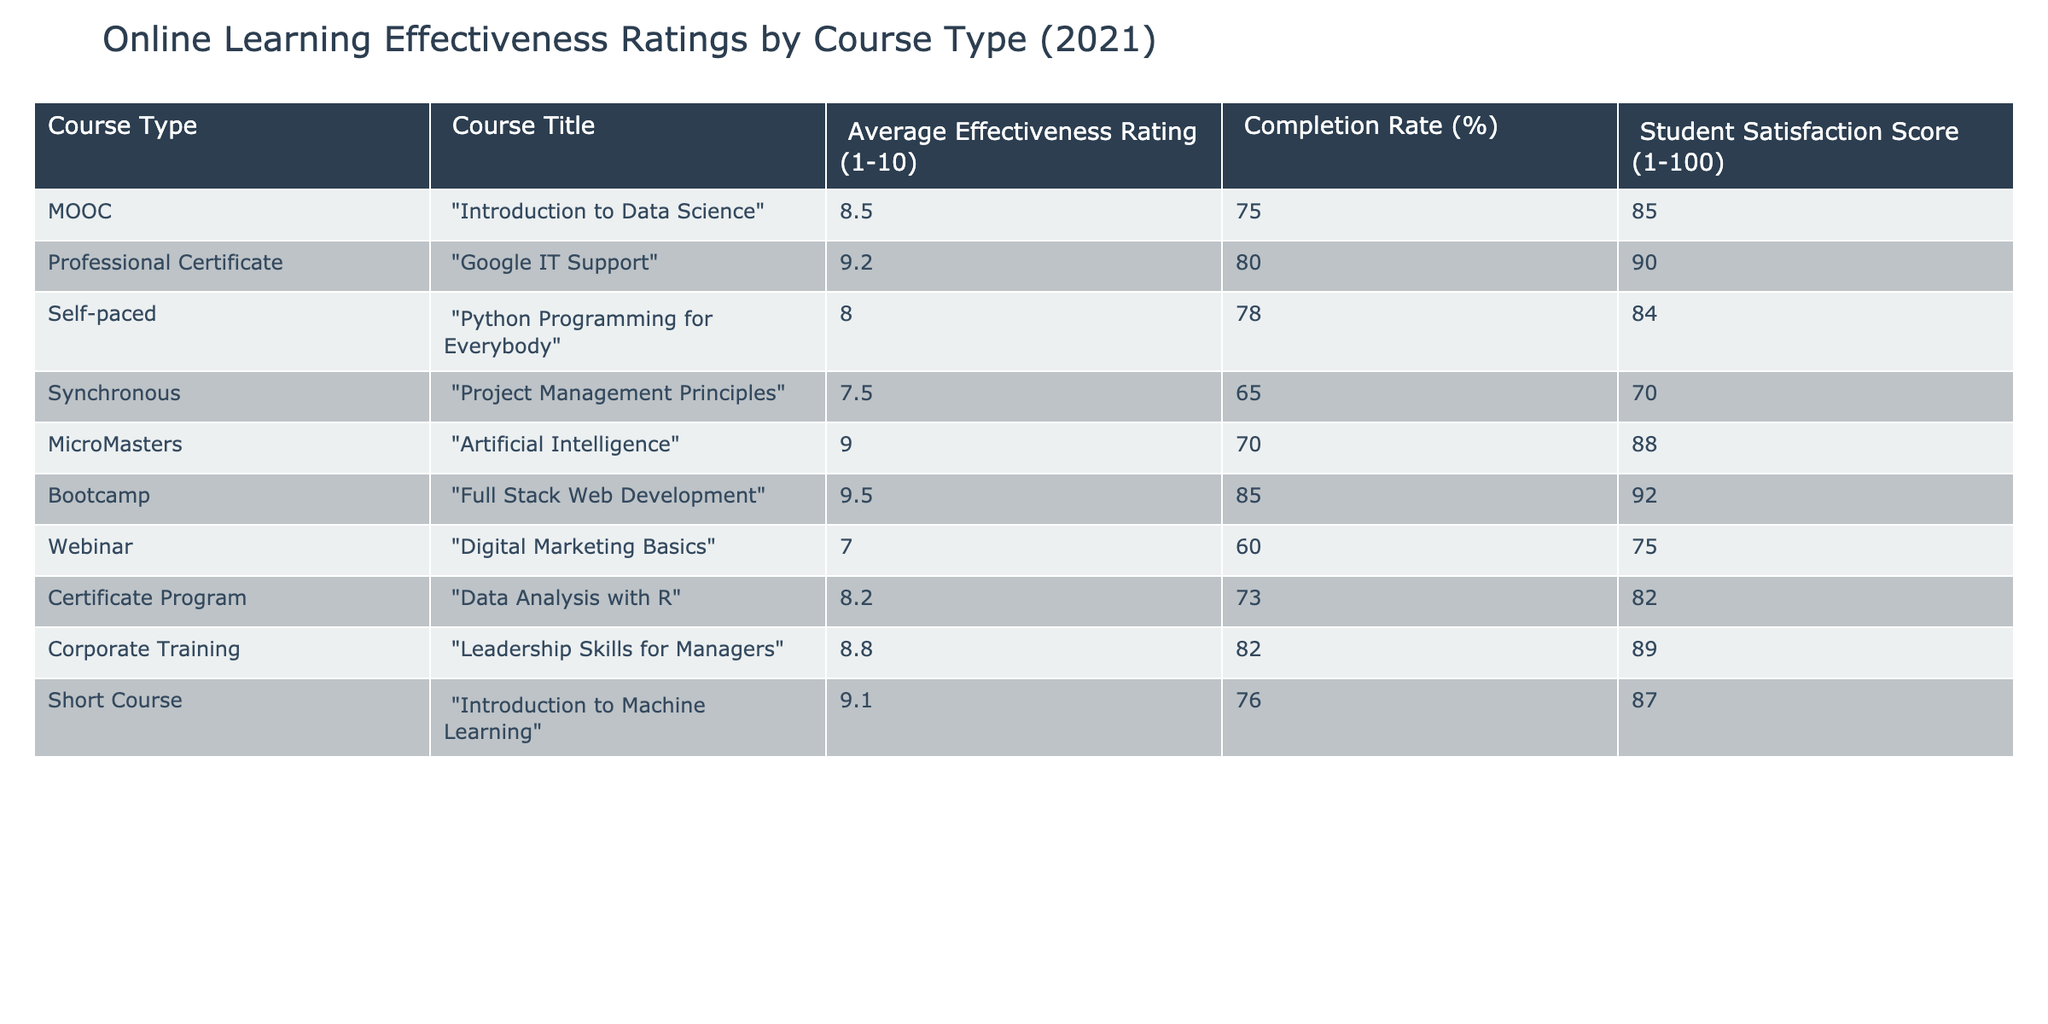What is the average effectiveness rating of the "Self-paced" course type? The effectiveness rating of the "Self-paced" course type is 8.0, as indicated in the respective row for "Python Programming for Everybody"
Answer: 8.0 Which course has the highest student satisfaction score? "Full Stack Web Development" has the highest student satisfaction score of 92, according to the data presented in the table
Answer: 92 Is the completion rate for "Artificial Intelligence" higher than 75%? The completion rate for "Artificial Intelligence" is 70%, which is lower than 75%, so the statement is false
Answer: No What is the difference in effectiveness ratings between the highest-rated course and the lowest-rated course? The highest-rated course is "Full Stack Web Development" with a rating of 9.5, and the lowest-rated course is "Digital Marketing Basics" with a rating of 7.0. The difference is 9.5 - 7.0 = 2.5
Answer: 2.5 What is the average completion rate for all the courses in the table? To find the average completion rate, we sum all completion rates: 75 + 80 + 78 + 65 + 70 + 85 + 60 + 73 + 82 + 76 =  784. There are 10 courses, so the average is 784 / 10 = 78.4
Answer: 78.4 Which course type has the same effectiveness rating as "Leadership Skills for Managers"? "Google IT Support" with a rating of 9.2 also corresponds to the Professional Certificate type, matching the systematic effectiveness rating of 8.8 for "Leadership Skills for Managers"
Answer: No Which course types have a completion rate of 80% or higher? The courses with a completion rate of 80% or higher are "Google IT Support" (80%), "Full Stack Web Development" (85%), and "Leadership Skills for Managers" (82%). Therefore, there are three such courses
Answer: 3 What is the student satisfaction score for the course type with the lowest completion rate? The course "Project Management Principles" has the lowest completion rate of 65%, and its corresponding student satisfaction score is 70
Answer: 70 How many courses have an effectiveness rating above 8.0? The courses with effectiveness ratings above 8.0 are "Introduction to Data Science" (8.5), "Google IT Support" (9.2), "Artificial Intelligence" (9.0), "Full Stack Web Development" (9.5), "Short Course" (9.1). This gives us a total of five courses above that threshold
Answer: 5 